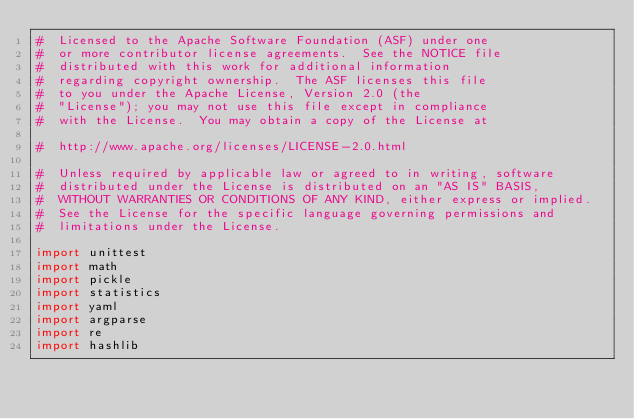<code> <loc_0><loc_0><loc_500><loc_500><_Python_>#  Licensed to the Apache Software Foundation (ASF) under one
#  or more contributor license agreements.  See the NOTICE file
#  distributed with this work for additional information
#  regarding copyright ownership.  The ASF licenses this file
#  to you under the Apache License, Version 2.0 (the
#  "License"); you may not use this file except in compliance
#  with the License.  You may obtain a copy of the License at

#  http://www.apache.org/licenses/LICENSE-2.0.html

#  Unless required by applicable law or agreed to in writing, software
#  distributed under the License is distributed on an "AS IS" BASIS,
#  WITHOUT WARRANTIES OR CONDITIONS OF ANY KIND, either express or implied.
#  See the License for the specific language governing permissions and
#  limitations under the License.

import unittest
import math
import pickle
import statistics
import yaml
import argparse
import re
import hashlib
</code> 